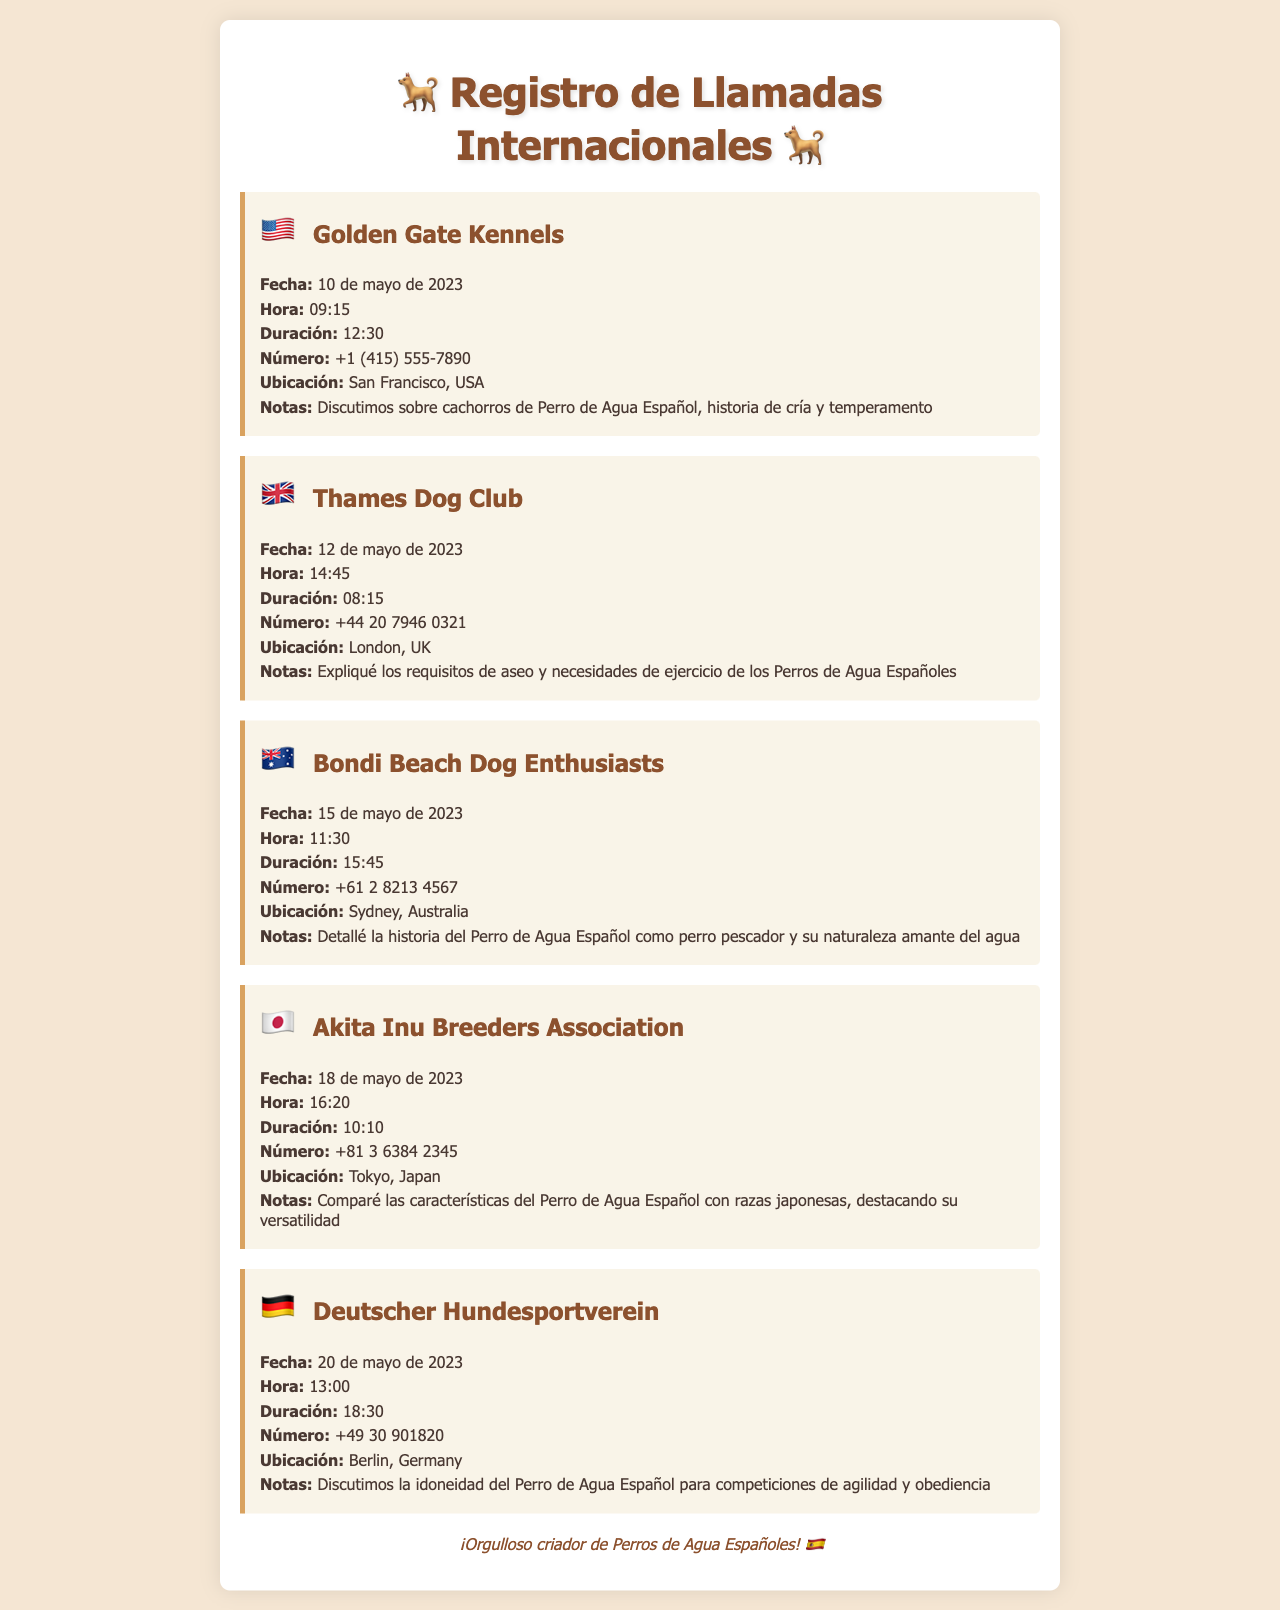¿Cuál es el nombre del primer contacto? El primer contacto listado es "Golden Gate Kennels".
Answer: Golden Gate Kennels ¿Cuál fue la duración de la llamada con Thames Dog Club? La duración de la llamada con Thames Dog Club fue de 8 minutos y 15 segundos.
Answer: 08:15 ¿Qué fecha tuvo la llamada con Bondi Beach Dog Enthusiasts? La fecha de la llamada con Bondi Beach Dog Enthusiasts fue el 15 de mayo de 2023.
Answer: 15 de mayo de 2023 ¿Cuál es el número de contacto de Deutscher Hundesportverein? El número de contacto de Deutscher Hundesportverein es +49 30 901820.
Answer: +49 30 901820 ¿Cuántos contactos están ubicados en Japón? Hay un contacto ubicado en Japón en la lista.
Answer: 1 ¿Qué se discutió en la llamada con Golden Gate Kennels? En la llamada con Golden Gate Kennels se discutió sobre cachorros de Perro de Agua Español, historia de cría y temperamento.
Answer: cachorros de Perro de Agua Español, historia de cría y temperamento ¿A qué hora se realizó la llamada a Bondi Beach Dog Enthusiasts? La llamada a Bondi Beach Dog Enthusiasts se realizó a las 11:30.
Answer: 11:30 ¿Cuál es la bandera que representa a Alemania en el documento? La bandera que representa a Alemania es la bandera nacional de Alemania.
Answer: 🇩🇪 